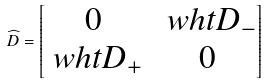<formula> <loc_0><loc_0><loc_500><loc_500>\widehat { D } = \begin{bmatrix} 0 & \ w h t { D } _ { - } \\ \ w h t { D } _ { + } & 0 \end{bmatrix}</formula> 